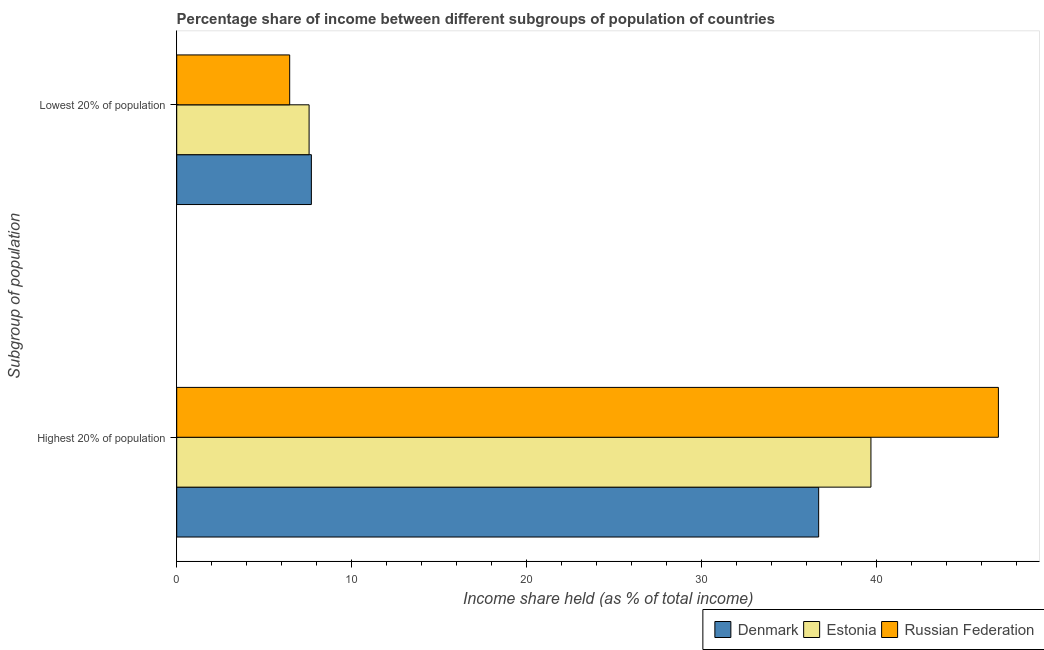How many different coloured bars are there?
Ensure brevity in your answer.  3. Are the number of bars per tick equal to the number of legend labels?
Offer a terse response. Yes. Are the number of bars on each tick of the Y-axis equal?
Your answer should be very brief. Yes. What is the label of the 2nd group of bars from the top?
Your answer should be very brief. Highest 20% of population. Across all countries, what is the minimum income share held by lowest 20% of the population?
Keep it short and to the point. 6.46. In which country was the income share held by lowest 20% of the population minimum?
Ensure brevity in your answer.  Russian Federation. What is the total income share held by lowest 20% of the population in the graph?
Your answer should be compact. 21.73. What is the difference between the income share held by highest 20% of the population in Russian Federation and that in Estonia?
Give a very brief answer. 7.29. What is the difference between the income share held by lowest 20% of the population in Denmark and the income share held by highest 20% of the population in Estonia?
Offer a very short reply. -32. What is the average income share held by highest 20% of the population per country?
Make the answer very short. 41.13. What is the difference between the income share held by lowest 20% of the population and income share held by highest 20% of the population in Russian Federation?
Provide a short and direct response. -40.53. In how many countries, is the income share held by lowest 20% of the population greater than 4 %?
Your answer should be very brief. 3. What is the ratio of the income share held by highest 20% of the population in Denmark to that in Russian Federation?
Ensure brevity in your answer.  0.78. What does the 2nd bar from the bottom in Lowest 20% of population represents?
Your response must be concise. Estonia. How many bars are there?
Provide a short and direct response. 6. How many countries are there in the graph?
Keep it short and to the point. 3. Does the graph contain any zero values?
Give a very brief answer. No. Does the graph contain grids?
Provide a succinct answer. No. What is the title of the graph?
Keep it short and to the point. Percentage share of income between different subgroups of population of countries. What is the label or title of the X-axis?
Provide a succinct answer. Income share held (as % of total income). What is the label or title of the Y-axis?
Offer a terse response. Subgroup of population. What is the Income share held (as % of total income) of Denmark in Highest 20% of population?
Provide a succinct answer. 36.71. What is the Income share held (as % of total income) in Estonia in Highest 20% of population?
Make the answer very short. 39.7. What is the Income share held (as % of total income) of Russian Federation in Highest 20% of population?
Provide a short and direct response. 46.99. What is the Income share held (as % of total income) in Denmark in Lowest 20% of population?
Make the answer very short. 7.7. What is the Income share held (as % of total income) of Estonia in Lowest 20% of population?
Your answer should be very brief. 7.57. What is the Income share held (as % of total income) in Russian Federation in Lowest 20% of population?
Ensure brevity in your answer.  6.46. Across all Subgroup of population, what is the maximum Income share held (as % of total income) in Denmark?
Keep it short and to the point. 36.71. Across all Subgroup of population, what is the maximum Income share held (as % of total income) in Estonia?
Offer a terse response. 39.7. Across all Subgroup of population, what is the maximum Income share held (as % of total income) of Russian Federation?
Offer a very short reply. 46.99. Across all Subgroup of population, what is the minimum Income share held (as % of total income) of Denmark?
Ensure brevity in your answer.  7.7. Across all Subgroup of population, what is the minimum Income share held (as % of total income) of Estonia?
Make the answer very short. 7.57. Across all Subgroup of population, what is the minimum Income share held (as % of total income) in Russian Federation?
Your response must be concise. 6.46. What is the total Income share held (as % of total income) in Denmark in the graph?
Offer a very short reply. 44.41. What is the total Income share held (as % of total income) of Estonia in the graph?
Provide a short and direct response. 47.27. What is the total Income share held (as % of total income) in Russian Federation in the graph?
Your answer should be compact. 53.45. What is the difference between the Income share held (as % of total income) of Denmark in Highest 20% of population and that in Lowest 20% of population?
Offer a very short reply. 29.01. What is the difference between the Income share held (as % of total income) in Estonia in Highest 20% of population and that in Lowest 20% of population?
Your answer should be compact. 32.13. What is the difference between the Income share held (as % of total income) in Russian Federation in Highest 20% of population and that in Lowest 20% of population?
Offer a terse response. 40.53. What is the difference between the Income share held (as % of total income) of Denmark in Highest 20% of population and the Income share held (as % of total income) of Estonia in Lowest 20% of population?
Your response must be concise. 29.14. What is the difference between the Income share held (as % of total income) in Denmark in Highest 20% of population and the Income share held (as % of total income) in Russian Federation in Lowest 20% of population?
Ensure brevity in your answer.  30.25. What is the difference between the Income share held (as % of total income) in Estonia in Highest 20% of population and the Income share held (as % of total income) in Russian Federation in Lowest 20% of population?
Offer a very short reply. 33.24. What is the average Income share held (as % of total income) of Denmark per Subgroup of population?
Keep it short and to the point. 22.2. What is the average Income share held (as % of total income) in Estonia per Subgroup of population?
Offer a very short reply. 23.64. What is the average Income share held (as % of total income) in Russian Federation per Subgroup of population?
Ensure brevity in your answer.  26.73. What is the difference between the Income share held (as % of total income) of Denmark and Income share held (as % of total income) of Estonia in Highest 20% of population?
Keep it short and to the point. -2.99. What is the difference between the Income share held (as % of total income) in Denmark and Income share held (as % of total income) in Russian Federation in Highest 20% of population?
Your answer should be very brief. -10.28. What is the difference between the Income share held (as % of total income) of Estonia and Income share held (as % of total income) of Russian Federation in Highest 20% of population?
Your answer should be very brief. -7.29. What is the difference between the Income share held (as % of total income) of Denmark and Income share held (as % of total income) of Estonia in Lowest 20% of population?
Your answer should be very brief. 0.13. What is the difference between the Income share held (as % of total income) of Denmark and Income share held (as % of total income) of Russian Federation in Lowest 20% of population?
Keep it short and to the point. 1.24. What is the difference between the Income share held (as % of total income) of Estonia and Income share held (as % of total income) of Russian Federation in Lowest 20% of population?
Provide a short and direct response. 1.11. What is the ratio of the Income share held (as % of total income) in Denmark in Highest 20% of population to that in Lowest 20% of population?
Your answer should be compact. 4.77. What is the ratio of the Income share held (as % of total income) of Estonia in Highest 20% of population to that in Lowest 20% of population?
Your answer should be very brief. 5.24. What is the ratio of the Income share held (as % of total income) of Russian Federation in Highest 20% of population to that in Lowest 20% of population?
Offer a very short reply. 7.27. What is the difference between the highest and the second highest Income share held (as % of total income) in Denmark?
Keep it short and to the point. 29.01. What is the difference between the highest and the second highest Income share held (as % of total income) of Estonia?
Keep it short and to the point. 32.13. What is the difference between the highest and the second highest Income share held (as % of total income) of Russian Federation?
Provide a short and direct response. 40.53. What is the difference between the highest and the lowest Income share held (as % of total income) of Denmark?
Provide a short and direct response. 29.01. What is the difference between the highest and the lowest Income share held (as % of total income) of Estonia?
Make the answer very short. 32.13. What is the difference between the highest and the lowest Income share held (as % of total income) in Russian Federation?
Offer a terse response. 40.53. 